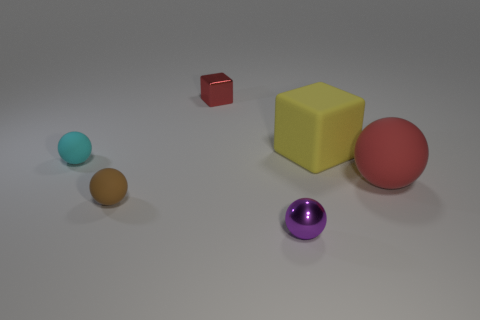How many small things are cyan shiny things or brown rubber spheres?
Your answer should be compact. 1. Are there more brown matte things than red rubber cylinders?
Offer a very short reply. Yes. There is a cube that is left of the metallic object right of the metal cube; what number of tiny cyan spheres are right of it?
Offer a terse response. 0. There is a small brown rubber thing; what shape is it?
Make the answer very short. Sphere. What number of other things are the same material as the tiny red cube?
Make the answer very short. 1. Does the cyan object have the same size as the purple ball?
Make the answer very short. Yes. The thing right of the large yellow object has what shape?
Offer a terse response. Sphere. The rubber ball that is on the right side of the big matte object that is on the left side of the red matte sphere is what color?
Keep it short and to the point. Red. There is a tiny metallic object on the left side of the purple shiny ball; is its shape the same as the large rubber thing that is behind the big red rubber thing?
Offer a terse response. Yes. There is a red thing that is the same size as the purple thing; what shape is it?
Give a very brief answer. Cube. 